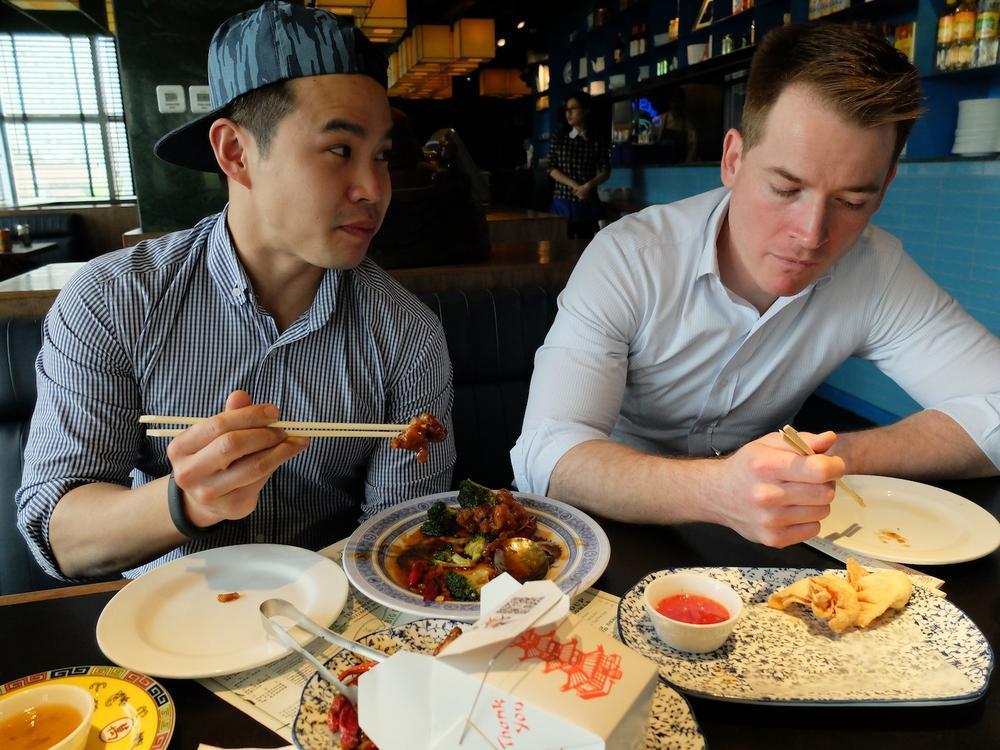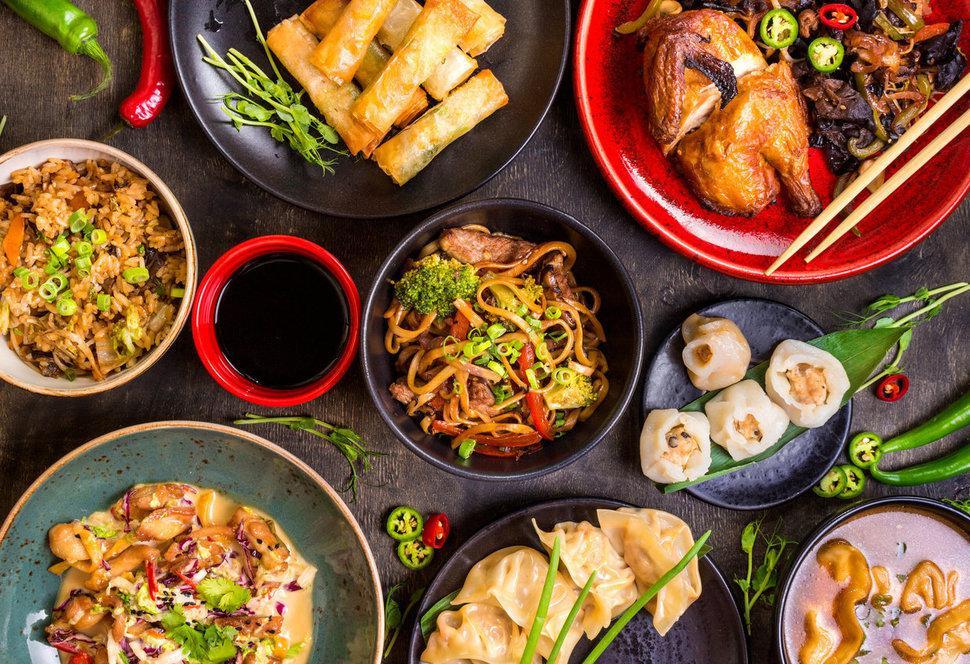The first image is the image on the left, the second image is the image on the right. For the images displayed, is the sentence "People are holding chopsticks in both images." factually correct? Answer yes or no. No. The first image is the image on the left, the second image is the image on the right. Given the left and right images, does the statement "In one of the images, four people are about to grab food from one plate, each using chop sticks." hold true? Answer yes or no. No. 